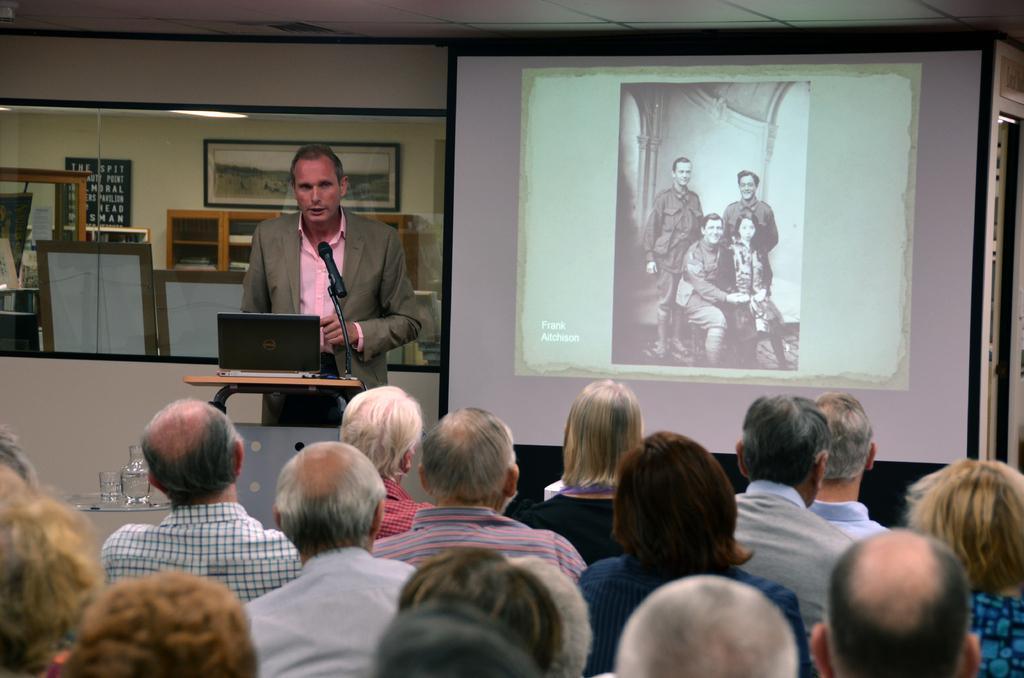Please provide a concise description of this image. In this picture we can see people sitting and looking at a man and projector display with a picture on it. We can see a table, a laptop, a mike, and glasses in front of the person. In the background, we can see glass window, mirror and frames. 